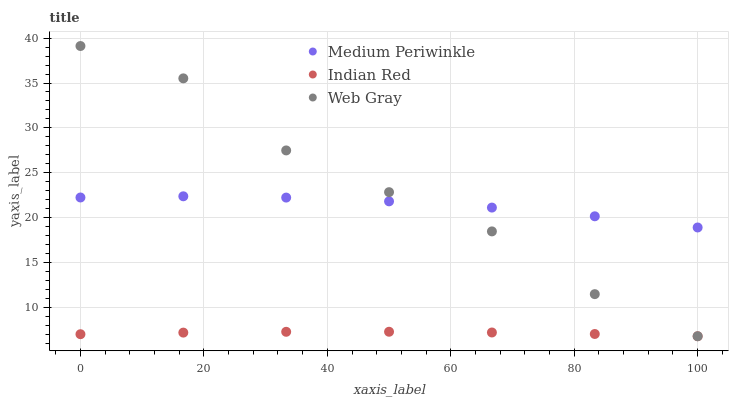Does Indian Red have the minimum area under the curve?
Answer yes or no. Yes. Does Web Gray have the maximum area under the curve?
Answer yes or no. Yes. Does Medium Periwinkle have the minimum area under the curve?
Answer yes or no. No. Does Medium Periwinkle have the maximum area under the curve?
Answer yes or no. No. Is Indian Red the smoothest?
Answer yes or no. Yes. Is Web Gray the roughest?
Answer yes or no. Yes. Is Medium Periwinkle the smoothest?
Answer yes or no. No. Is Medium Periwinkle the roughest?
Answer yes or no. No. Does Indian Red have the lowest value?
Answer yes or no. Yes. Does Medium Periwinkle have the lowest value?
Answer yes or no. No. Does Web Gray have the highest value?
Answer yes or no. Yes. Does Medium Periwinkle have the highest value?
Answer yes or no. No. Is Indian Red less than Web Gray?
Answer yes or no. Yes. Is Medium Periwinkle greater than Indian Red?
Answer yes or no. Yes. Does Medium Periwinkle intersect Web Gray?
Answer yes or no. Yes. Is Medium Periwinkle less than Web Gray?
Answer yes or no. No. Is Medium Periwinkle greater than Web Gray?
Answer yes or no. No. Does Indian Red intersect Web Gray?
Answer yes or no. No. 